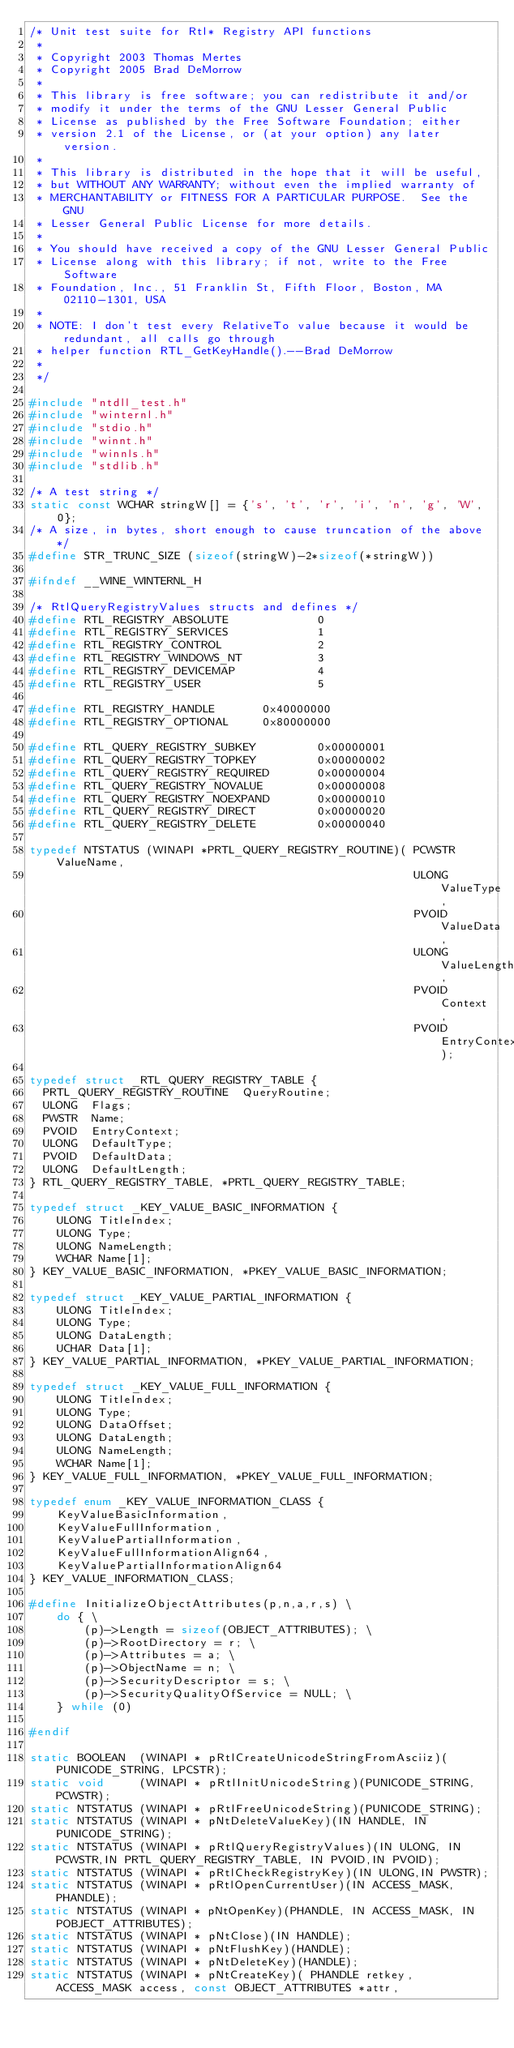<code> <loc_0><loc_0><loc_500><loc_500><_C_>/* Unit test suite for Rtl* Registry API functions
 *
 * Copyright 2003 Thomas Mertes
 * Copyright 2005 Brad DeMorrow
 *
 * This library is free software; you can redistribute it and/or
 * modify it under the terms of the GNU Lesser General Public
 * License as published by the Free Software Foundation; either
 * version 2.1 of the License, or (at your option) any later version.
 *
 * This library is distributed in the hope that it will be useful,
 * but WITHOUT ANY WARRANTY; without even the implied warranty of
 * MERCHANTABILITY or FITNESS FOR A PARTICULAR PURPOSE.  See the GNU
 * Lesser General Public License for more details.
 *
 * You should have received a copy of the GNU Lesser General Public
 * License along with this library; if not, write to the Free Software
 * Foundation, Inc., 51 Franklin St, Fifth Floor, Boston, MA 02110-1301, USA
 *
 * NOTE: I don't test every RelativeTo value because it would be redundant, all calls go through
 * helper function RTL_GetKeyHandle().--Brad DeMorrow
 *
 */

#include "ntdll_test.h"
#include "winternl.h"
#include "stdio.h"
#include "winnt.h"
#include "winnls.h"
#include "stdlib.h"

/* A test string */
static const WCHAR stringW[] = {'s', 't', 'r', 'i', 'n', 'g', 'W', 0};
/* A size, in bytes, short enough to cause truncation of the above */
#define STR_TRUNC_SIZE (sizeof(stringW)-2*sizeof(*stringW))

#ifndef __WINE_WINTERNL_H

/* RtlQueryRegistryValues structs and defines */
#define RTL_REGISTRY_ABSOLUTE             0
#define RTL_REGISTRY_SERVICES             1
#define RTL_REGISTRY_CONTROL              2
#define RTL_REGISTRY_WINDOWS_NT           3
#define RTL_REGISTRY_DEVICEMAP            4
#define RTL_REGISTRY_USER                 5

#define RTL_REGISTRY_HANDLE       0x40000000
#define RTL_REGISTRY_OPTIONAL     0x80000000

#define RTL_QUERY_REGISTRY_SUBKEY         0x00000001
#define RTL_QUERY_REGISTRY_TOPKEY         0x00000002
#define RTL_QUERY_REGISTRY_REQUIRED       0x00000004
#define RTL_QUERY_REGISTRY_NOVALUE        0x00000008
#define RTL_QUERY_REGISTRY_NOEXPAND       0x00000010
#define RTL_QUERY_REGISTRY_DIRECT         0x00000020
#define RTL_QUERY_REGISTRY_DELETE         0x00000040

typedef NTSTATUS (WINAPI *PRTL_QUERY_REGISTRY_ROUTINE)( PCWSTR  ValueName,
                                                        ULONG  ValueType,
                                                        PVOID  ValueData,
                                                        ULONG  ValueLength,
                                                        PVOID  Context,
                                                        PVOID  EntryContext);

typedef struct _RTL_QUERY_REGISTRY_TABLE {
  PRTL_QUERY_REGISTRY_ROUTINE  QueryRoutine;
  ULONG  Flags;
  PWSTR  Name;
  PVOID  EntryContext;
  ULONG  DefaultType;
  PVOID  DefaultData;
  ULONG  DefaultLength;
} RTL_QUERY_REGISTRY_TABLE, *PRTL_QUERY_REGISTRY_TABLE;

typedef struct _KEY_VALUE_BASIC_INFORMATION {
    ULONG TitleIndex;
    ULONG Type;
    ULONG NameLength;
    WCHAR Name[1];
} KEY_VALUE_BASIC_INFORMATION, *PKEY_VALUE_BASIC_INFORMATION;

typedef struct _KEY_VALUE_PARTIAL_INFORMATION {
    ULONG TitleIndex;
    ULONG Type;
    ULONG DataLength;
    UCHAR Data[1];
} KEY_VALUE_PARTIAL_INFORMATION, *PKEY_VALUE_PARTIAL_INFORMATION;

typedef struct _KEY_VALUE_FULL_INFORMATION {
    ULONG TitleIndex;
    ULONG Type;
    ULONG DataOffset;
    ULONG DataLength;
    ULONG NameLength;
    WCHAR Name[1];
} KEY_VALUE_FULL_INFORMATION, *PKEY_VALUE_FULL_INFORMATION;

typedef enum _KEY_VALUE_INFORMATION_CLASS {
    KeyValueBasicInformation,
    KeyValueFullInformation,
    KeyValuePartialInformation,
    KeyValueFullInformationAlign64,
    KeyValuePartialInformationAlign64
} KEY_VALUE_INFORMATION_CLASS;

#define InitializeObjectAttributes(p,n,a,r,s) \
    do { \
        (p)->Length = sizeof(OBJECT_ATTRIBUTES); \
        (p)->RootDirectory = r; \
        (p)->Attributes = a; \
        (p)->ObjectName = n; \
        (p)->SecurityDescriptor = s; \
        (p)->SecurityQualityOfService = NULL; \
    } while (0)

#endif

static BOOLEAN  (WINAPI * pRtlCreateUnicodeStringFromAsciiz)(PUNICODE_STRING, LPCSTR);
static void     (WINAPI * pRtlInitUnicodeString)(PUNICODE_STRING,PCWSTR);
static NTSTATUS (WINAPI * pRtlFreeUnicodeString)(PUNICODE_STRING);
static NTSTATUS (WINAPI * pNtDeleteValueKey)(IN HANDLE, IN PUNICODE_STRING);
static NTSTATUS (WINAPI * pRtlQueryRegistryValues)(IN ULONG, IN PCWSTR,IN PRTL_QUERY_REGISTRY_TABLE, IN PVOID,IN PVOID);
static NTSTATUS (WINAPI * pRtlCheckRegistryKey)(IN ULONG,IN PWSTR);
static NTSTATUS (WINAPI * pRtlOpenCurrentUser)(IN ACCESS_MASK, PHANDLE);
static NTSTATUS (WINAPI * pNtOpenKey)(PHANDLE, IN ACCESS_MASK, IN POBJECT_ATTRIBUTES);
static NTSTATUS (WINAPI * pNtClose)(IN HANDLE);
static NTSTATUS (WINAPI * pNtFlushKey)(HANDLE);
static NTSTATUS (WINAPI * pNtDeleteKey)(HANDLE);
static NTSTATUS (WINAPI * pNtCreateKey)( PHANDLE retkey, ACCESS_MASK access, const OBJECT_ATTRIBUTES *attr,</code> 